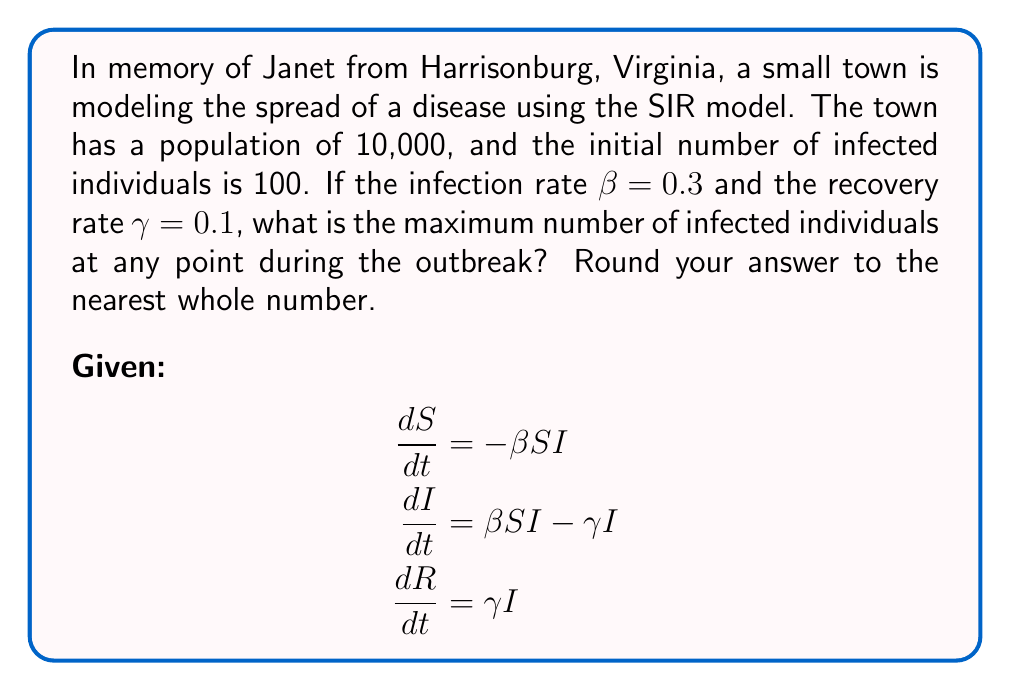Teach me how to tackle this problem. To find the maximum number of infected individuals, we need to follow these steps:

1) First, we need to calculate the basic reproduction number $R_0$:
   $R_0 = \frac{\beta}{\gamma} = \frac{0.3}{0.1} = 3$

2) The maximum number of infected individuals occurs when $\frac{dI}{dt} = 0$. At this point:
   $\beta SI - \gamma I = 0$
   $S = \frac{\gamma}{\beta} = \frac{1}{R_0} = \frac{1}{3}$

3) We can use the conservation of population equation:
   $S + I + R = N$ (where N is the total population)
   At the start: $S_0 + I_0 + R_0 = 10,000$
   $S_0 = 9,900$, $I_0 = 100$, $R_0 = 0$

4) We can also use the final size equation:
   $\ln(\frac{S_0}{S_{\infty}}) = R_0(1-\frac{S_{\infty}}{N})$

5) Substituting the values:
   $\ln(\frac{9,900}{10,000/3}) = 3(1-\frac{10,000/3}{10,000})$
   $\ln(2.97) = 3(1-\frac{1}{3}) = 2$

6) This confirms our calculation of $S_{\infty} = \frac{N}{3} = \frac{10,000}{3}$

7) At the peak of infection:
   $I_{max} = N - S_{\infty} - R_{\infty}$
   $R_{\infty}$ can be calculated as: $R_{\infty} = N(1-\frac{S_{\infty}}{S_0})$
   $R_{\infty} = 10,000(1-\frac{10,000/3}{9,900}) = 6,633$

8) Therefore:
   $I_{max} = 10,000 - \frac{10,000}{3} - 6,633 = 33$

9) Rounding to the nearest whole number: 33
Answer: 33 